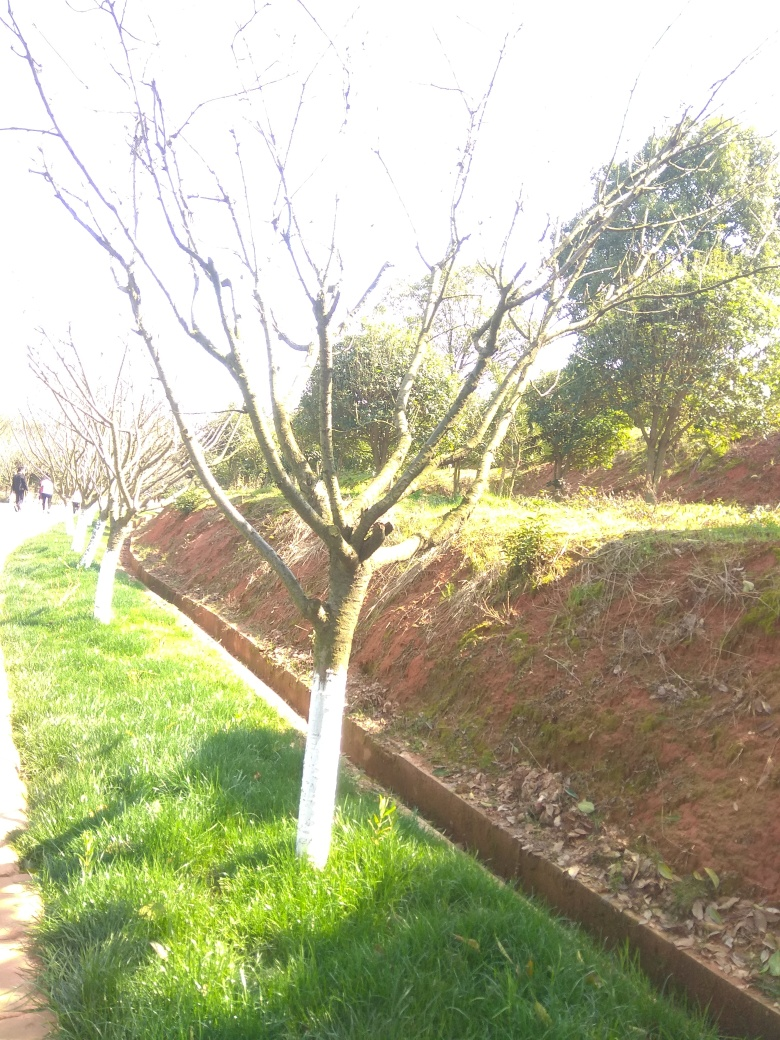How would you rate the quality of this photo?
A. Above average
B. Below average
C. Excellent
D. Outstanding Considering the composition and lighting of the photo, I would rate it as below average. The photo is overexposed, resulting in lost detail in the brightly lit sections. Also, the subject of the photo, the trees, do not stand out against the background due to the lack of contrast. 